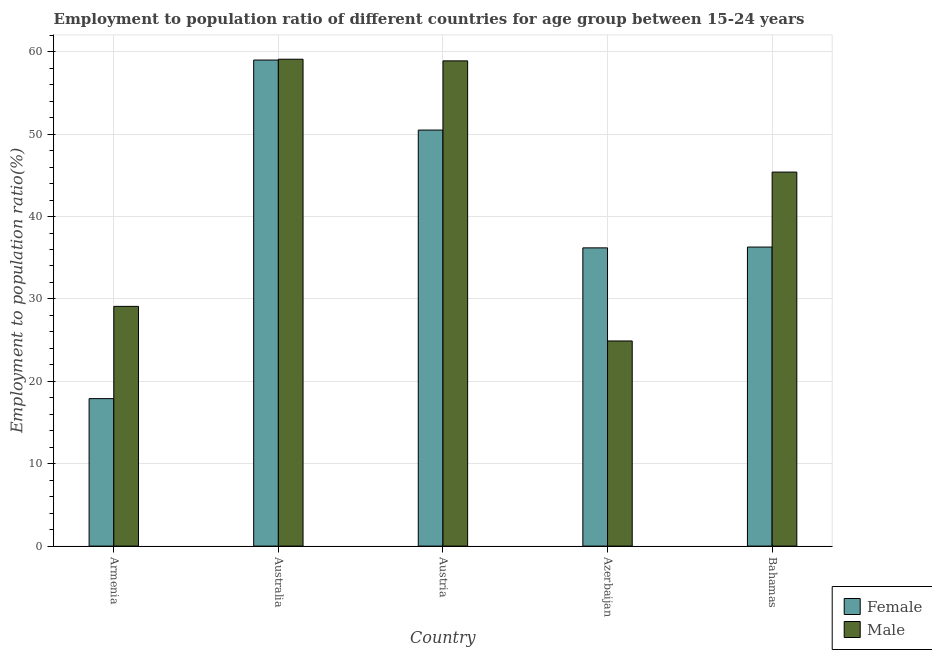How many groups of bars are there?
Provide a short and direct response. 5. How many bars are there on the 5th tick from the right?
Your response must be concise. 2. What is the label of the 4th group of bars from the left?
Your response must be concise. Azerbaijan. What is the employment to population ratio(female) in Austria?
Ensure brevity in your answer.  50.5. Across all countries, what is the maximum employment to population ratio(female)?
Make the answer very short. 59. Across all countries, what is the minimum employment to population ratio(female)?
Give a very brief answer. 17.9. In which country was the employment to population ratio(male) minimum?
Your answer should be compact. Azerbaijan. What is the total employment to population ratio(male) in the graph?
Make the answer very short. 217.4. What is the difference between the employment to population ratio(male) in Australia and that in Austria?
Make the answer very short. 0.2. What is the difference between the employment to population ratio(female) in Bahamas and the employment to population ratio(male) in Azerbaijan?
Offer a very short reply. 11.4. What is the average employment to population ratio(male) per country?
Provide a succinct answer. 43.48. What is the difference between the employment to population ratio(male) and employment to population ratio(female) in Austria?
Keep it short and to the point. 8.4. In how many countries, is the employment to population ratio(female) greater than 20 %?
Your response must be concise. 4. What is the ratio of the employment to population ratio(male) in Azerbaijan to that in Bahamas?
Keep it short and to the point. 0.55. Is the employment to population ratio(female) in Australia less than that in Bahamas?
Provide a short and direct response. No. Is the difference between the employment to population ratio(male) in Armenia and Australia greater than the difference between the employment to population ratio(female) in Armenia and Australia?
Provide a succinct answer. Yes. What is the difference between the highest and the second highest employment to population ratio(male)?
Make the answer very short. 0.2. What is the difference between the highest and the lowest employment to population ratio(male)?
Provide a succinct answer. 34.2. In how many countries, is the employment to population ratio(male) greater than the average employment to population ratio(male) taken over all countries?
Give a very brief answer. 3. How many bars are there?
Give a very brief answer. 10. Are all the bars in the graph horizontal?
Provide a short and direct response. No. Does the graph contain grids?
Ensure brevity in your answer.  Yes. How many legend labels are there?
Your answer should be very brief. 2. What is the title of the graph?
Your response must be concise. Employment to population ratio of different countries for age group between 15-24 years. What is the Employment to population ratio(%) in Female in Armenia?
Make the answer very short. 17.9. What is the Employment to population ratio(%) in Male in Armenia?
Ensure brevity in your answer.  29.1. What is the Employment to population ratio(%) in Female in Australia?
Offer a terse response. 59. What is the Employment to population ratio(%) of Male in Australia?
Give a very brief answer. 59.1. What is the Employment to population ratio(%) in Female in Austria?
Offer a terse response. 50.5. What is the Employment to population ratio(%) of Male in Austria?
Make the answer very short. 58.9. What is the Employment to population ratio(%) in Female in Azerbaijan?
Make the answer very short. 36.2. What is the Employment to population ratio(%) in Male in Azerbaijan?
Offer a very short reply. 24.9. What is the Employment to population ratio(%) of Female in Bahamas?
Your answer should be compact. 36.3. What is the Employment to population ratio(%) in Male in Bahamas?
Provide a short and direct response. 45.4. Across all countries, what is the maximum Employment to population ratio(%) of Male?
Ensure brevity in your answer.  59.1. Across all countries, what is the minimum Employment to population ratio(%) in Female?
Offer a very short reply. 17.9. Across all countries, what is the minimum Employment to population ratio(%) of Male?
Offer a terse response. 24.9. What is the total Employment to population ratio(%) in Female in the graph?
Your answer should be compact. 199.9. What is the total Employment to population ratio(%) in Male in the graph?
Your answer should be very brief. 217.4. What is the difference between the Employment to population ratio(%) in Female in Armenia and that in Australia?
Give a very brief answer. -41.1. What is the difference between the Employment to population ratio(%) in Female in Armenia and that in Austria?
Your answer should be very brief. -32.6. What is the difference between the Employment to population ratio(%) of Male in Armenia and that in Austria?
Provide a short and direct response. -29.8. What is the difference between the Employment to population ratio(%) in Female in Armenia and that in Azerbaijan?
Your answer should be very brief. -18.3. What is the difference between the Employment to population ratio(%) of Male in Armenia and that in Azerbaijan?
Keep it short and to the point. 4.2. What is the difference between the Employment to population ratio(%) in Female in Armenia and that in Bahamas?
Your answer should be very brief. -18.4. What is the difference between the Employment to population ratio(%) in Male in Armenia and that in Bahamas?
Make the answer very short. -16.3. What is the difference between the Employment to population ratio(%) in Female in Australia and that in Austria?
Provide a short and direct response. 8.5. What is the difference between the Employment to population ratio(%) in Male in Australia and that in Austria?
Offer a terse response. 0.2. What is the difference between the Employment to population ratio(%) of Female in Australia and that in Azerbaijan?
Make the answer very short. 22.8. What is the difference between the Employment to population ratio(%) of Male in Australia and that in Azerbaijan?
Offer a terse response. 34.2. What is the difference between the Employment to population ratio(%) in Female in Australia and that in Bahamas?
Offer a terse response. 22.7. What is the difference between the Employment to population ratio(%) of Male in Australia and that in Bahamas?
Keep it short and to the point. 13.7. What is the difference between the Employment to population ratio(%) in Female in Austria and that in Azerbaijan?
Ensure brevity in your answer.  14.3. What is the difference between the Employment to population ratio(%) in Male in Austria and that in Azerbaijan?
Keep it short and to the point. 34. What is the difference between the Employment to population ratio(%) in Male in Austria and that in Bahamas?
Your response must be concise. 13.5. What is the difference between the Employment to population ratio(%) in Female in Azerbaijan and that in Bahamas?
Provide a succinct answer. -0.1. What is the difference between the Employment to population ratio(%) of Male in Azerbaijan and that in Bahamas?
Give a very brief answer. -20.5. What is the difference between the Employment to population ratio(%) of Female in Armenia and the Employment to population ratio(%) of Male in Australia?
Provide a short and direct response. -41.2. What is the difference between the Employment to population ratio(%) of Female in Armenia and the Employment to population ratio(%) of Male in Austria?
Offer a terse response. -41. What is the difference between the Employment to population ratio(%) of Female in Armenia and the Employment to population ratio(%) of Male in Bahamas?
Provide a succinct answer. -27.5. What is the difference between the Employment to population ratio(%) in Female in Australia and the Employment to population ratio(%) in Male in Austria?
Make the answer very short. 0.1. What is the difference between the Employment to population ratio(%) of Female in Australia and the Employment to population ratio(%) of Male in Azerbaijan?
Ensure brevity in your answer.  34.1. What is the difference between the Employment to population ratio(%) of Female in Austria and the Employment to population ratio(%) of Male in Azerbaijan?
Keep it short and to the point. 25.6. What is the difference between the Employment to population ratio(%) in Female in Austria and the Employment to population ratio(%) in Male in Bahamas?
Your response must be concise. 5.1. What is the average Employment to population ratio(%) in Female per country?
Keep it short and to the point. 39.98. What is the average Employment to population ratio(%) in Male per country?
Make the answer very short. 43.48. What is the difference between the Employment to population ratio(%) of Female and Employment to population ratio(%) of Male in Armenia?
Give a very brief answer. -11.2. What is the difference between the Employment to population ratio(%) in Female and Employment to population ratio(%) in Male in Australia?
Your answer should be very brief. -0.1. What is the difference between the Employment to population ratio(%) of Female and Employment to population ratio(%) of Male in Austria?
Your response must be concise. -8.4. What is the difference between the Employment to population ratio(%) of Female and Employment to population ratio(%) of Male in Azerbaijan?
Your response must be concise. 11.3. What is the ratio of the Employment to population ratio(%) of Female in Armenia to that in Australia?
Make the answer very short. 0.3. What is the ratio of the Employment to population ratio(%) of Male in Armenia to that in Australia?
Your answer should be compact. 0.49. What is the ratio of the Employment to population ratio(%) of Female in Armenia to that in Austria?
Provide a succinct answer. 0.35. What is the ratio of the Employment to population ratio(%) of Male in Armenia to that in Austria?
Give a very brief answer. 0.49. What is the ratio of the Employment to population ratio(%) in Female in Armenia to that in Azerbaijan?
Your answer should be compact. 0.49. What is the ratio of the Employment to population ratio(%) in Male in Armenia to that in Azerbaijan?
Ensure brevity in your answer.  1.17. What is the ratio of the Employment to population ratio(%) of Female in Armenia to that in Bahamas?
Provide a short and direct response. 0.49. What is the ratio of the Employment to population ratio(%) in Male in Armenia to that in Bahamas?
Ensure brevity in your answer.  0.64. What is the ratio of the Employment to population ratio(%) of Female in Australia to that in Austria?
Your answer should be very brief. 1.17. What is the ratio of the Employment to population ratio(%) of Female in Australia to that in Azerbaijan?
Offer a terse response. 1.63. What is the ratio of the Employment to population ratio(%) in Male in Australia to that in Azerbaijan?
Your response must be concise. 2.37. What is the ratio of the Employment to population ratio(%) in Female in Australia to that in Bahamas?
Offer a terse response. 1.63. What is the ratio of the Employment to population ratio(%) of Male in Australia to that in Bahamas?
Your answer should be compact. 1.3. What is the ratio of the Employment to population ratio(%) in Female in Austria to that in Azerbaijan?
Ensure brevity in your answer.  1.4. What is the ratio of the Employment to population ratio(%) of Male in Austria to that in Azerbaijan?
Provide a succinct answer. 2.37. What is the ratio of the Employment to population ratio(%) in Female in Austria to that in Bahamas?
Offer a terse response. 1.39. What is the ratio of the Employment to population ratio(%) of Male in Austria to that in Bahamas?
Offer a very short reply. 1.3. What is the ratio of the Employment to population ratio(%) in Female in Azerbaijan to that in Bahamas?
Provide a short and direct response. 1. What is the ratio of the Employment to population ratio(%) in Male in Azerbaijan to that in Bahamas?
Offer a terse response. 0.55. What is the difference between the highest and the second highest Employment to population ratio(%) in Female?
Provide a short and direct response. 8.5. What is the difference between the highest and the second highest Employment to population ratio(%) in Male?
Provide a succinct answer. 0.2. What is the difference between the highest and the lowest Employment to population ratio(%) in Female?
Make the answer very short. 41.1. What is the difference between the highest and the lowest Employment to population ratio(%) in Male?
Offer a very short reply. 34.2. 